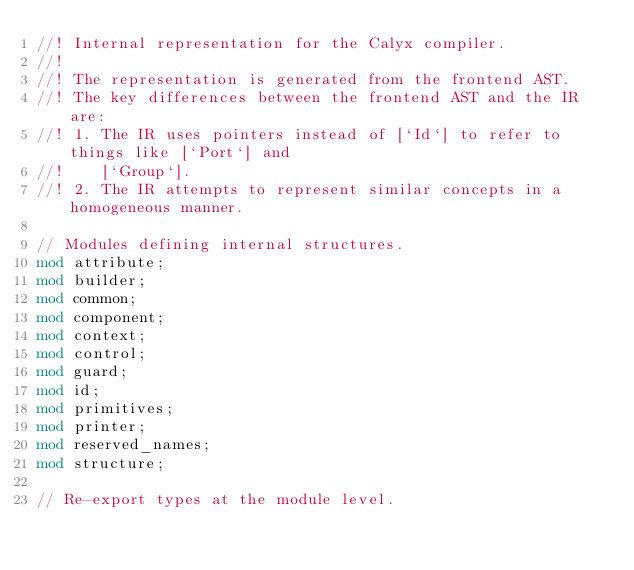<code> <loc_0><loc_0><loc_500><loc_500><_Rust_>//! Internal representation for the Calyx compiler.
//!
//! The representation is generated from the frontend AST.
//! The key differences between the frontend AST and the IR are:
//! 1. The IR uses pointers instead of [`Id`] to refer to things like [`Port`] and
//!    [`Group`].
//! 2. The IR attempts to represent similar concepts in a homogeneous manner.

// Modules defining internal structures.
mod attribute;
mod builder;
mod common;
mod component;
mod context;
mod control;
mod guard;
mod id;
mod primitives;
mod printer;
mod reserved_names;
mod structure;

// Re-export types at the module level.</code> 